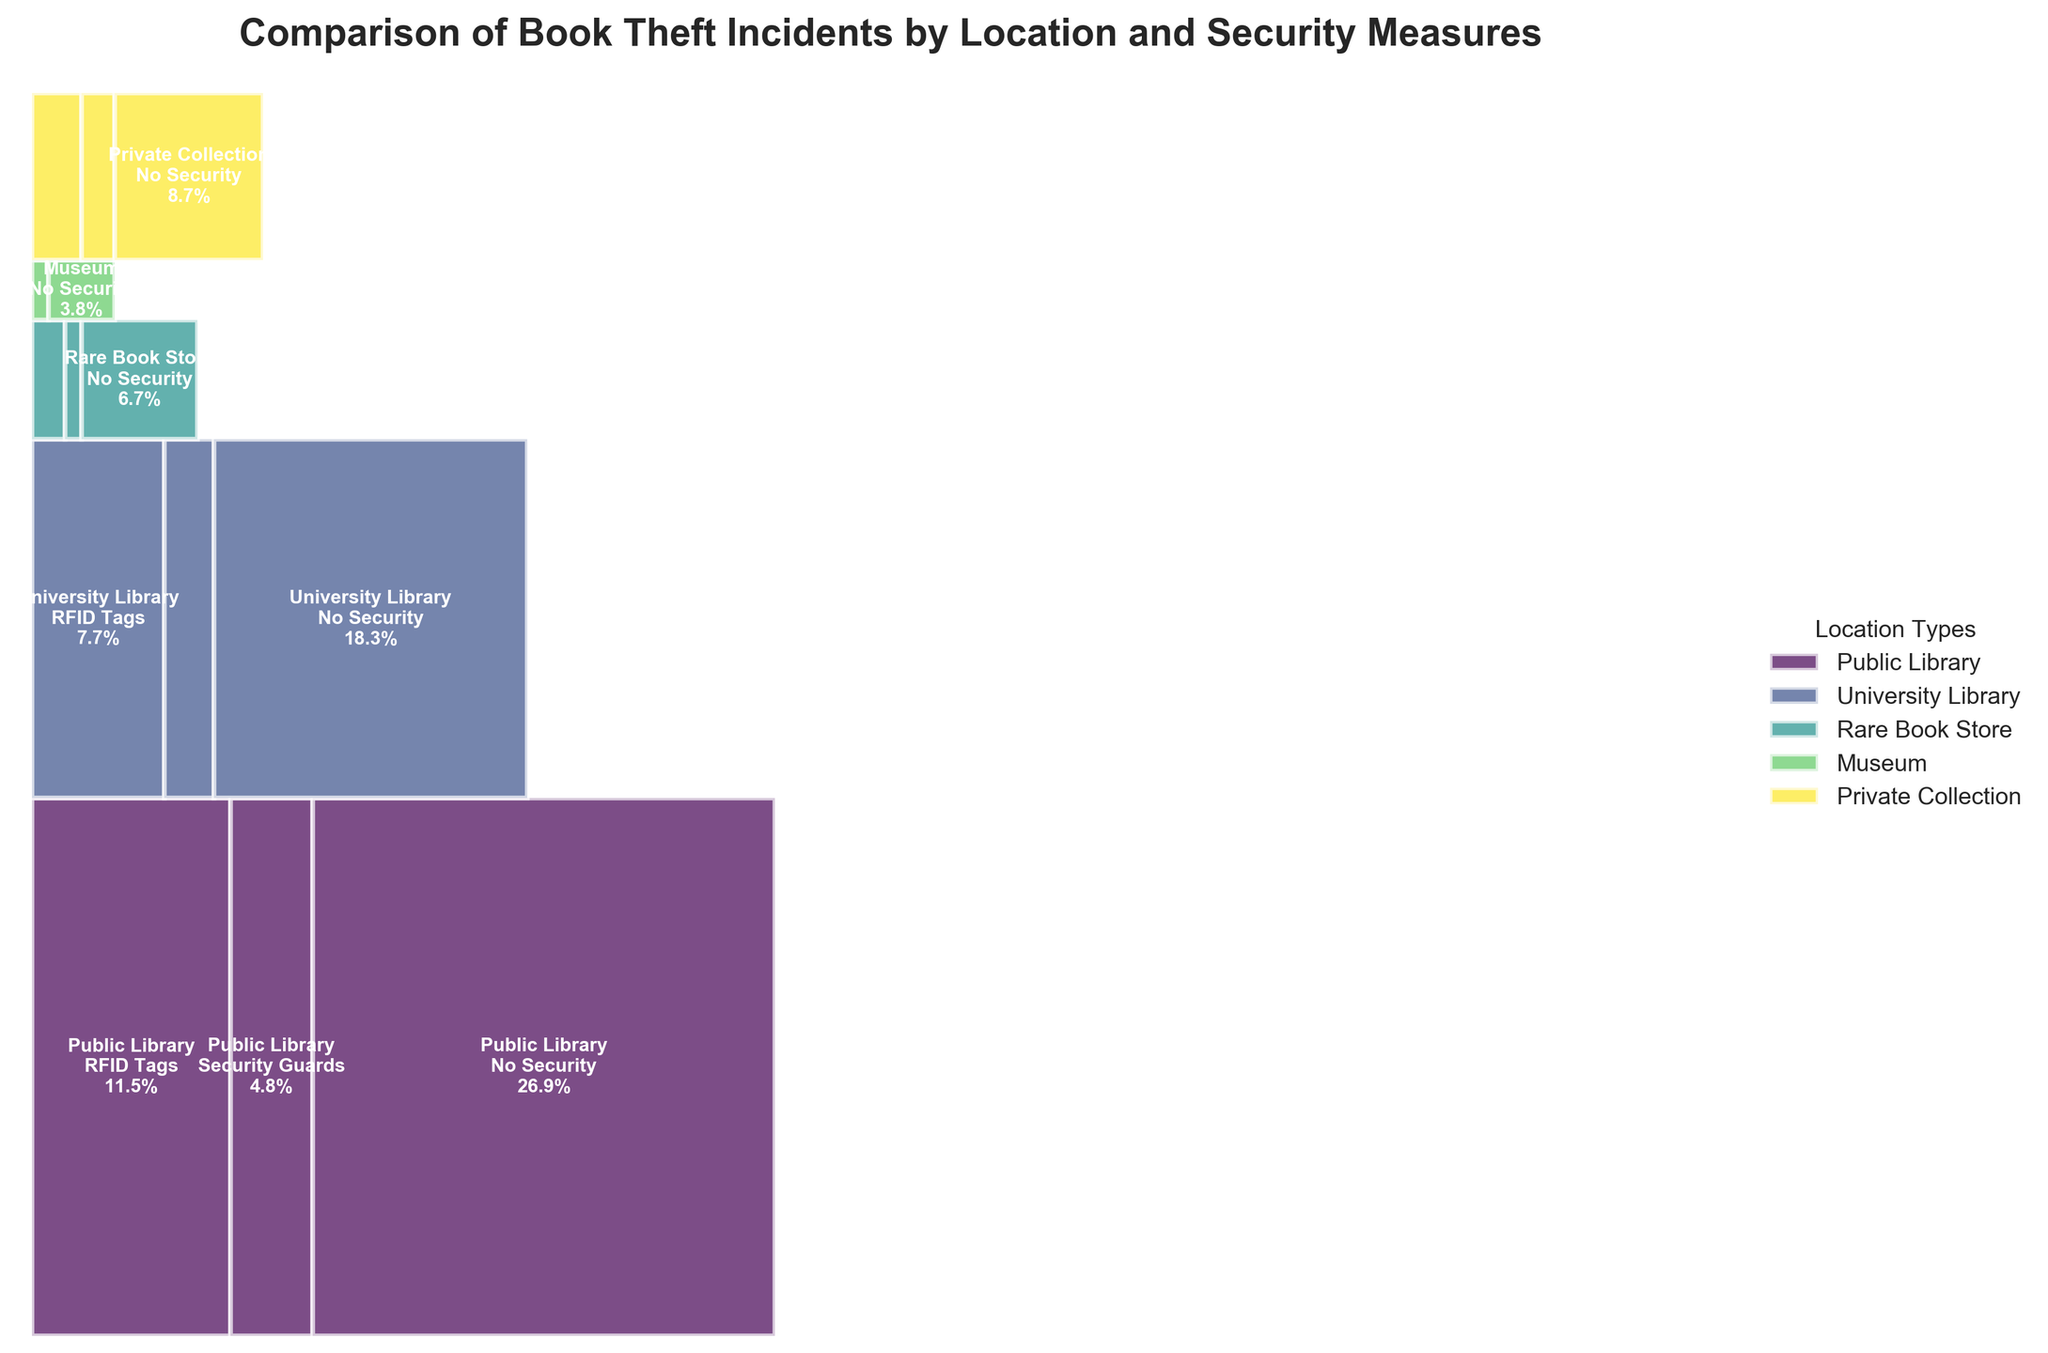What is the title of the mosaic plot? The title of the mosaic plot is usually located at the top and provides a summary of the overall visualization content. In this case, the title can be directly read from the plot.
Answer: Comparison of Book Theft Incidents by Location and Security Measures Which location type has the highest proportion of theft incidents? By looking at the largest section across all location types in the mosaic plot, one can see the relative proportions of theft incidents. Compare the sizes visually. The largest section belongs to "Public Library".
Answer: Public Library How many different security measures are compared in the plot? Count the number of unique segmented bars within any given location type section in the mosaic plot. The "Security Measure" categories should be consistent across different "Location Type" categories.
Answer: 3 Which specific combination of location type and security measure has the lowest proportion of theft incidents? Identify the smallest segment within the mosaic plot. This will be a combination of a specific location type and security measure. The smallest section appears to be "Museum" with "Security Guards".
Answer: Museum with Security Guards Which location type has the most theft incidents when RFID tags are used? Compare the widths of the rectangles corresponding to RFID tags across different location types, and identify the one with the largest proportion. "Public Library" has the largest segment for RFID tags.
Answer: Public Library What proportion of theft incidents occur in rare book stores with no security? Look for the segment representing "Rare Book Store" combined with "No Security" and read the percentage from the plot.
Answer: 1.75% How does the proportion of theft incidents at university libraries with no security compare to that at public libraries with no security? Compare the segments for "University Library" with "No Security" and "Public Library" with "No Security". Determine which one is larger and by roughly what proportion or difference. "Public Library" with no security has a larger section than "University Library".
Answer: Public Library Which security measure appears to be the most effective in reducing theft incidents across all location types? Identify the segments within each location type that are the smallest and note the corresponding security measure. If "Security Guards" consistently has the smallest segments, it suggests effectiveness. "Security Guards" consistently appear to have lower proportions.
Answer: Security Guards Summing up, what is the proportion of theft incidents occurring at museums and rare book stores together? Add the segments corresponding to all security measures for both "Museum" and "Rare Book Store" and sum the proportions. Sum calculations lead to the combined proportion displayed.
Answer: 2.35% Which location type has fewer theft incidents with security guards compared to no security? By visually comparing the proportions for a combination of location type with "Security Guards" and "No Security", determine whether the security guards' segment is smaller. Check "Public Library" and "University Library".
Answer: All locations with Security Guards have fewer theft incidents compared to No Security 